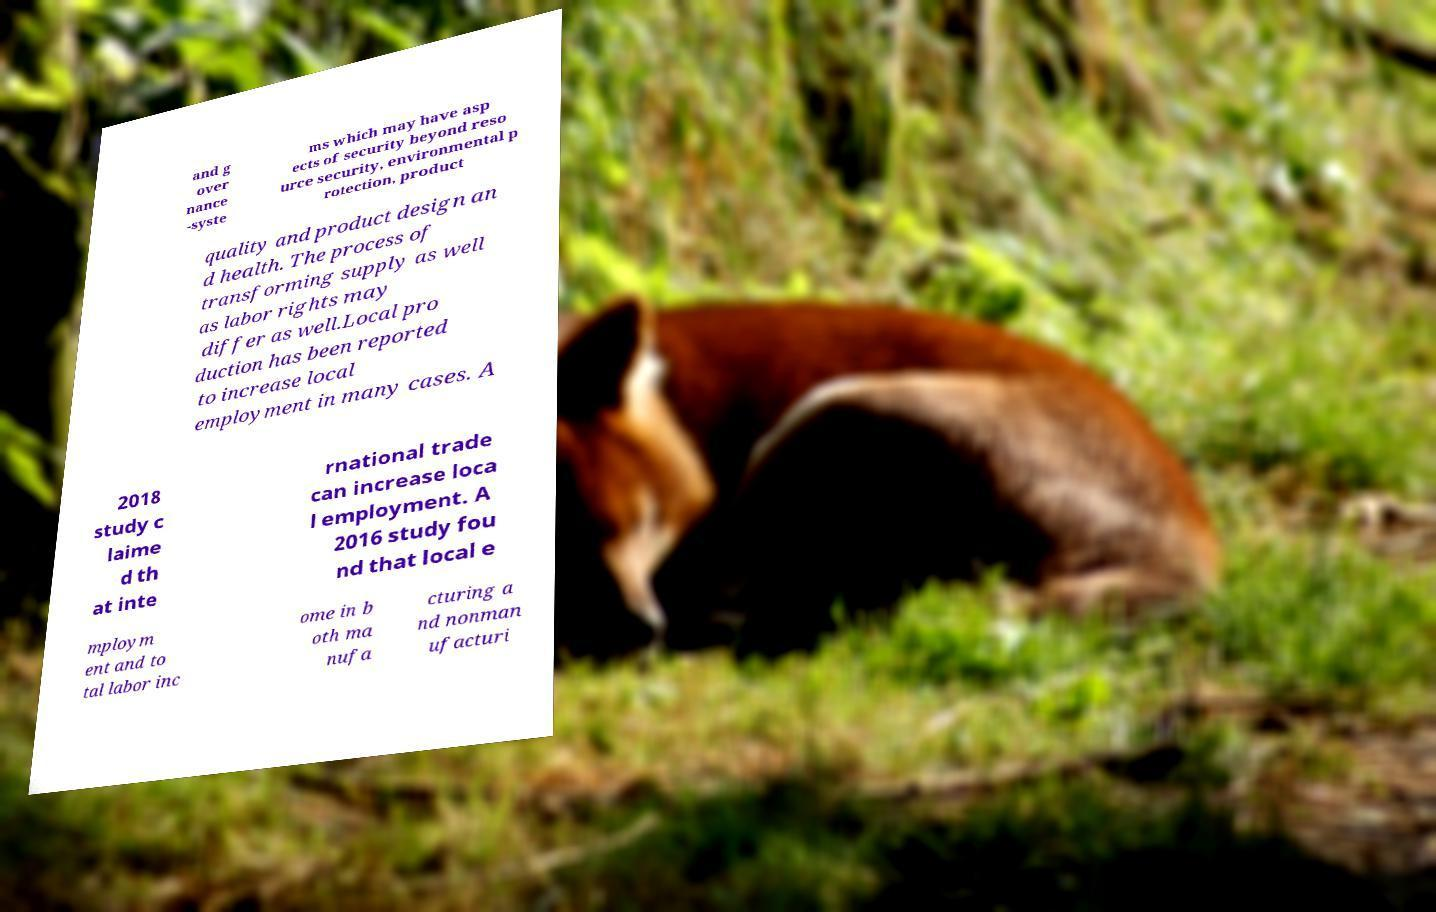Can you accurately transcribe the text from the provided image for me? and g over nance -syste ms which may have asp ects of security beyond reso urce security, environmental p rotection, product quality and product design an d health. The process of transforming supply as well as labor rights may differ as well.Local pro duction has been reported to increase local employment in many cases. A 2018 study c laime d th at inte rnational trade can increase loca l employment. A 2016 study fou nd that local e mploym ent and to tal labor inc ome in b oth ma nufa cturing a nd nonman ufacturi 